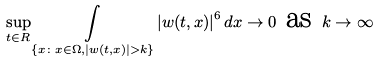Convert formula to latex. <formula><loc_0><loc_0><loc_500><loc_500>\underset { t \in R } { \sup } \underset { \left \{ x \colon x \in { \Omega , } \left | w ( t , x ) \right | > k \right \} } { \int } \left | w ( t , x ) \right | ^ { 6 } d x \rightarrow 0 \text { as } k \rightarrow \infty</formula> 